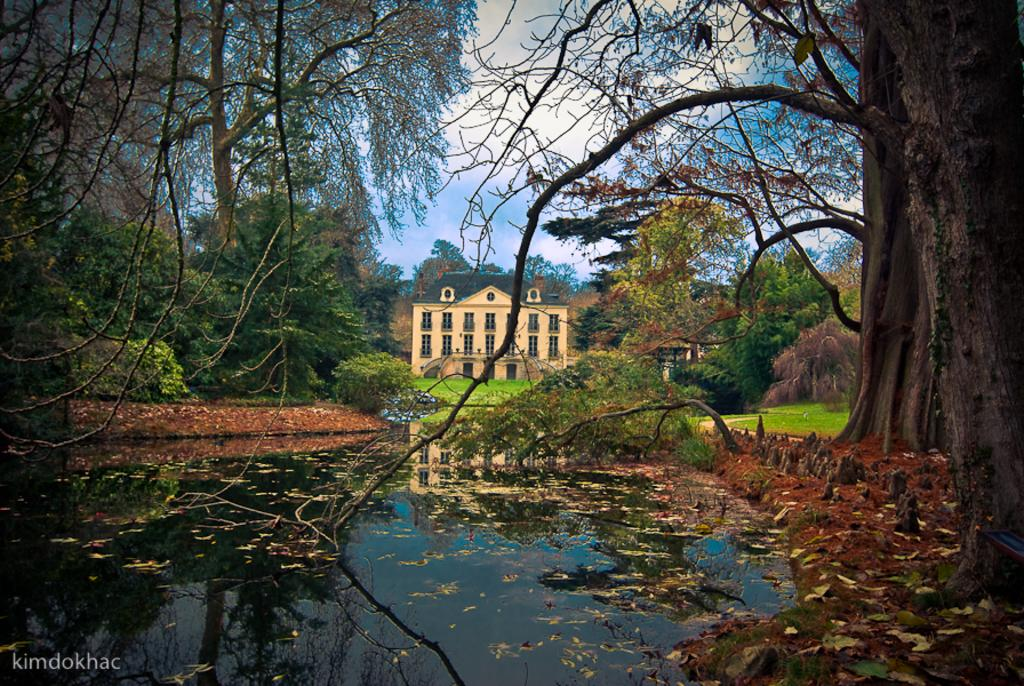What type of structure is present in the image? There is a house in the image. What type of vegetation can be seen in the image? There are trees, plants, and grass in the image. What part of the natural environment is visible in the image? The sky is visible in the image. What type of cracker is being used to create the smoke in the image? There is no cracker or smoke present in the image. What type of iron is visible in the image? There is no iron present in the image. 